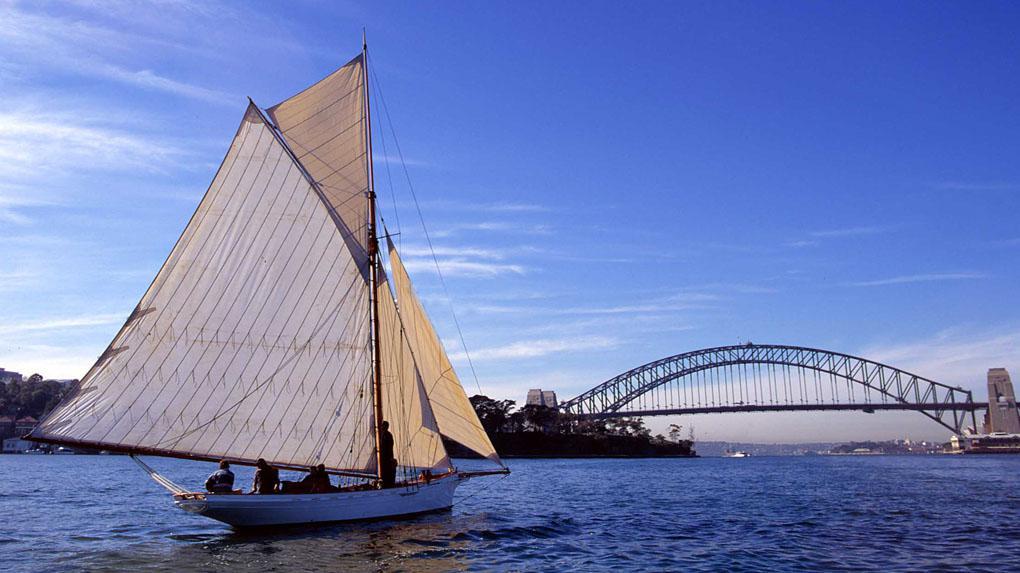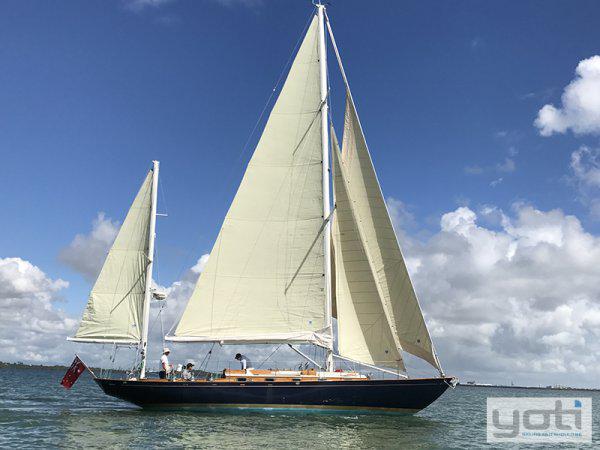The first image is the image on the left, the second image is the image on the right. Evaluate the accuracy of this statement regarding the images: "The sky in the image on the right is cloudless.". Is it true? Answer yes or no. No. 